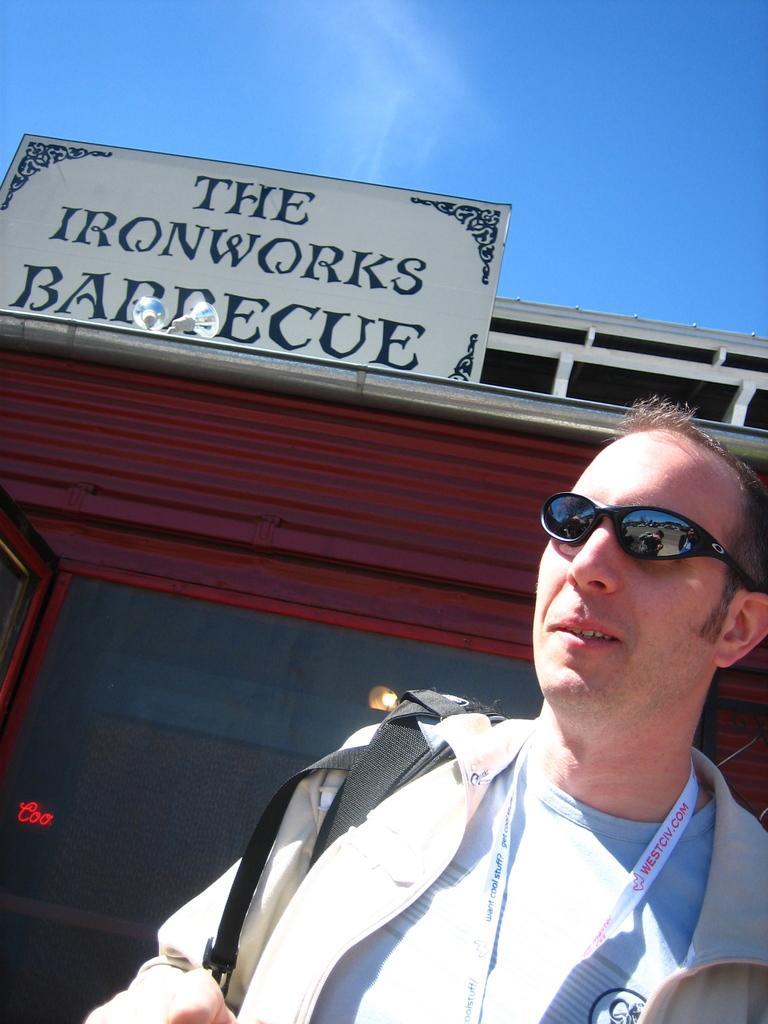Could you give a brief overview of what you see in this image? In this image we can see a person. In the background there is a board and we can see a building. At the top there is sky. 